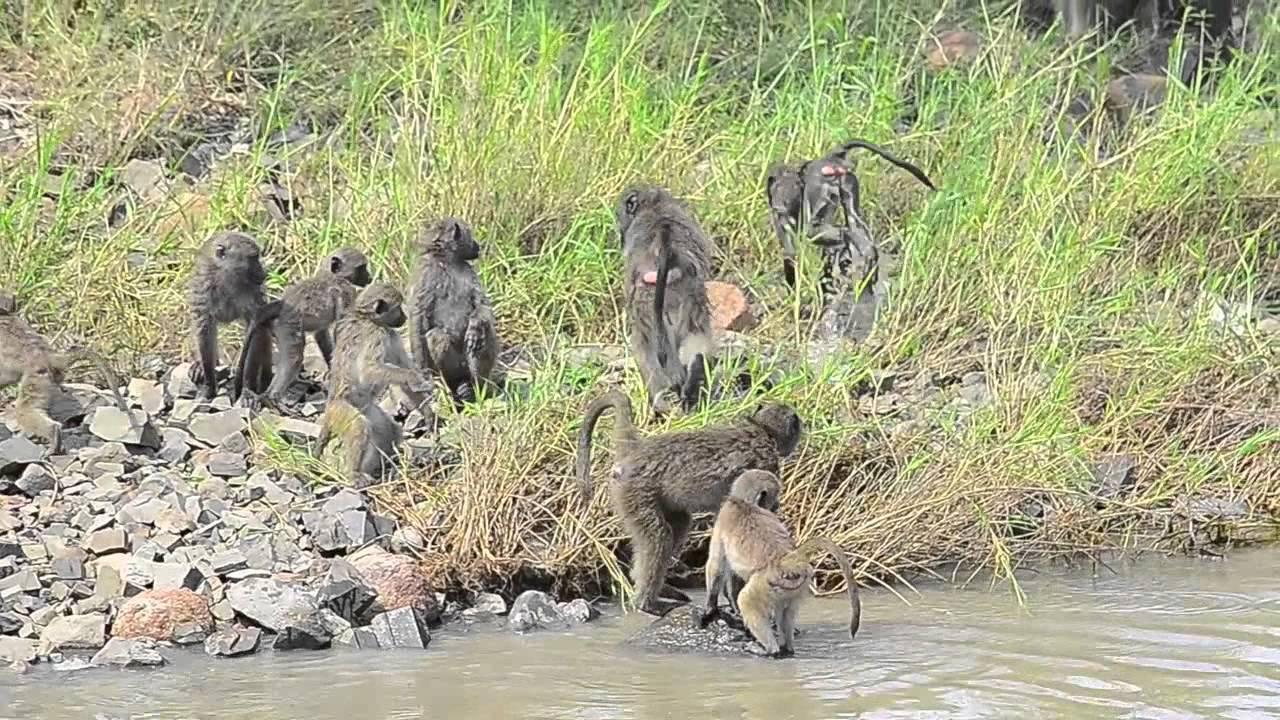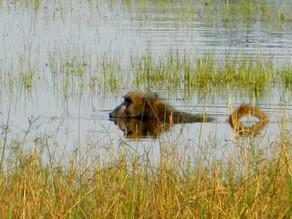The first image is the image on the left, the second image is the image on the right. For the images shown, is this caption "The left image includes at least one baboon perched on a cement ledge next to water, and the right image includes at least one baboon neck-deep in water." true? Answer yes or no. No. The first image is the image on the left, the second image is the image on the right. Assess this claim about the two images: "The monkey in the right image is in the water.". Correct or not? Answer yes or no. Yes. 